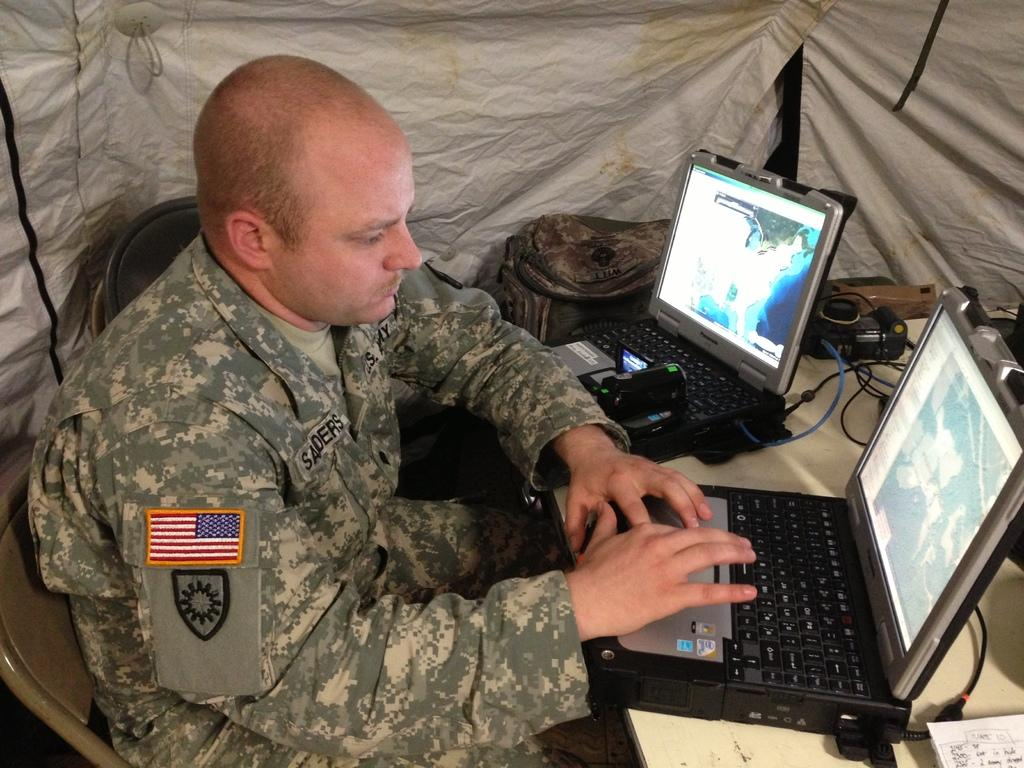<image>
Write a terse but informative summary of the picture. A soldier named Saders is typing on a laptop. 